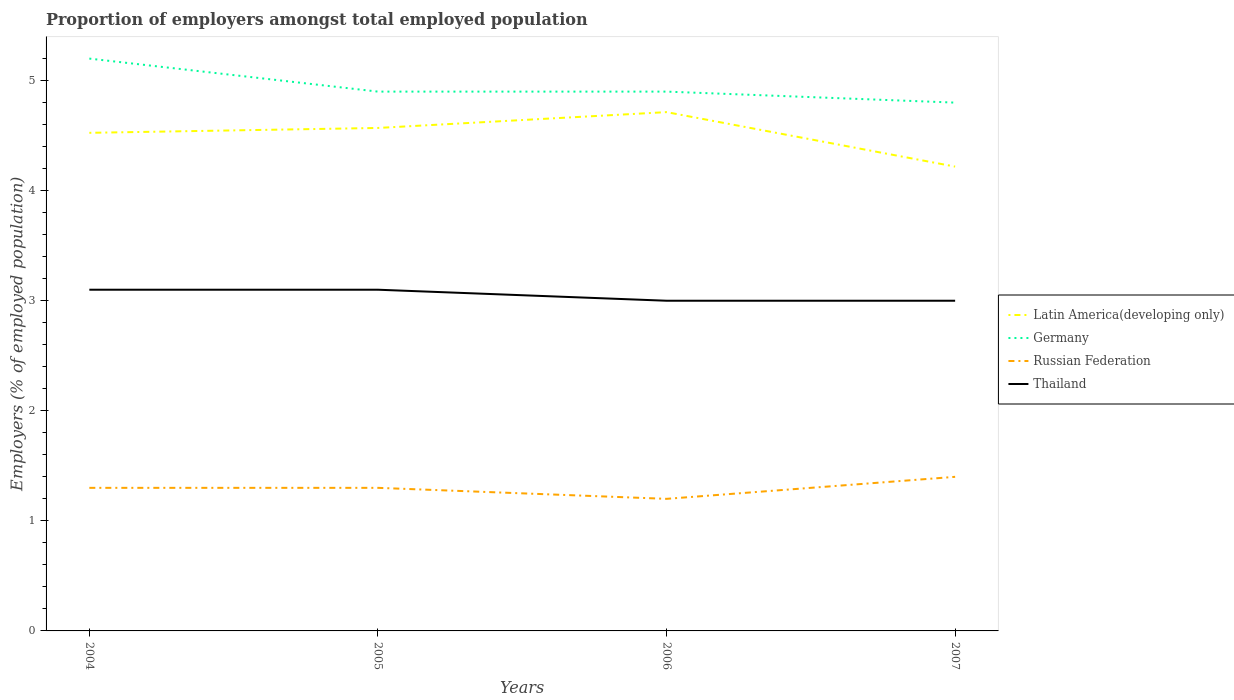Does the line corresponding to Thailand intersect with the line corresponding to Germany?
Your answer should be compact. No. Across all years, what is the maximum proportion of employers in Germany?
Offer a very short reply. 4.8. In which year was the proportion of employers in Thailand maximum?
Give a very brief answer. 2006. What is the total proportion of employers in Russian Federation in the graph?
Give a very brief answer. 0. What is the difference between the highest and the second highest proportion of employers in Germany?
Your answer should be very brief. 0.4. What is the difference between the highest and the lowest proportion of employers in Latin America(developing only)?
Give a very brief answer. 3. How many lines are there?
Make the answer very short. 4. What is the difference between two consecutive major ticks on the Y-axis?
Give a very brief answer. 1. Does the graph contain any zero values?
Give a very brief answer. No. Does the graph contain grids?
Give a very brief answer. No. How many legend labels are there?
Offer a very short reply. 4. What is the title of the graph?
Offer a terse response. Proportion of employers amongst total employed population. What is the label or title of the Y-axis?
Give a very brief answer. Employers (% of employed population). What is the Employers (% of employed population) in Latin America(developing only) in 2004?
Provide a short and direct response. 4.53. What is the Employers (% of employed population) of Germany in 2004?
Provide a succinct answer. 5.2. What is the Employers (% of employed population) of Russian Federation in 2004?
Provide a short and direct response. 1.3. What is the Employers (% of employed population) of Thailand in 2004?
Offer a terse response. 3.1. What is the Employers (% of employed population) in Latin America(developing only) in 2005?
Provide a short and direct response. 4.57. What is the Employers (% of employed population) in Germany in 2005?
Your answer should be compact. 4.9. What is the Employers (% of employed population) in Russian Federation in 2005?
Ensure brevity in your answer.  1.3. What is the Employers (% of employed population) in Thailand in 2005?
Offer a terse response. 3.1. What is the Employers (% of employed population) in Latin America(developing only) in 2006?
Offer a very short reply. 4.71. What is the Employers (% of employed population) of Germany in 2006?
Ensure brevity in your answer.  4.9. What is the Employers (% of employed population) in Russian Federation in 2006?
Make the answer very short. 1.2. What is the Employers (% of employed population) of Latin America(developing only) in 2007?
Your response must be concise. 4.22. What is the Employers (% of employed population) in Germany in 2007?
Provide a succinct answer. 4.8. What is the Employers (% of employed population) of Russian Federation in 2007?
Provide a short and direct response. 1.4. Across all years, what is the maximum Employers (% of employed population) in Latin America(developing only)?
Provide a succinct answer. 4.71. Across all years, what is the maximum Employers (% of employed population) in Germany?
Ensure brevity in your answer.  5.2. Across all years, what is the maximum Employers (% of employed population) in Russian Federation?
Ensure brevity in your answer.  1.4. Across all years, what is the maximum Employers (% of employed population) in Thailand?
Your response must be concise. 3.1. Across all years, what is the minimum Employers (% of employed population) in Latin America(developing only)?
Your response must be concise. 4.22. Across all years, what is the minimum Employers (% of employed population) of Germany?
Your answer should be compact. 4.8. Across all years, what is the minimum Employers (% of employed population) in Russian Federation?
Ensure brevity in your answer.  1.2. What is the total Employers (% of employed population) of Latin America(developing only) in the graph?
Offer a very short reply. 18.03. What is the total Employers (% of employed population) of Germany in the graph?
Your response must be concise. 19.8. What is the difference between the Employers (% of employed population) of Latin America(developing only) in 2004 and that in 2005?
Ensure brevity in your answer.  -0.04. What is the difference between the Employers (% of employed population) of Russian Federation in 2004 and that in 2005?
Provide a short and direct response. 0. What is the difference between the Employers (% of employed population) of Thailand in 2004 and that in 2005?
Your answer should be compact. 0. What is the difference between the Employers (% of employed population) in Latin America(developing only) in 2004 and that in 2006?
Your answer should be compact. -0.19. What is the difference between the Employers (% of employed population) of Latin America(developing only) in 2004 and that in 2007?
Provide a short and direct response. 0.31. What is the difference between the Employers (% of employed population) in Thailand in 2004 and that in 2007?
Your answer should be very brief. 0.1. What is the difference between the Employers (% of employed population) in Latin America(developing only) in 2005 and that in 2006?
Offer a very short reply. -0.14. What is the difference between the Employers (% of employed population) of Germany in 2005 and that in 2006?
Give a very brief answer. 0. What is the difference between the Employers (% of employed population) in Russian Federation in 2005 and that in 2006?
Offer a very short reply. 0.1. What is the difference between the Employers (% of employed population) of Latin America(developing only) in 2005 and that in 2007?
Provide a succinct answer. 0.35. What is the difference between the Employers (% of employed population) in Russian Federation in 2005 and that in 2007?
Your answer should be compact. -0.1. What is the difference between the Employers (% of employed population) in Latin America(developing only) in 2006 and that in 2007?
Keep it short and to the point. 0.49. What is the difference between the Employers (% of employed population) in Russian Federation in 2006 and that in 2007?
Offer a terse response. -0.2. What is the difference between the Employers (% of employed population) in Latin America(developing only) in 2004 and the Employers (% of employed population) in Germany in 2005?
Offer a very short reply. -0.37. What is the difference between the Employers (% of employed population) in Latin America(developing only) in 2004 and the Employers (% of employed population) in Russian Federation in 2005?
Provide a succinct answer. 3.23. What is the difference between the Employers (% of employed population) of Latin America(developing only) in 2004 and the Employers (% of employed population) of Thailand in 2005?
Your answer should be compact. 1.43. What is the difference between the Employers (% of employed population) in Germany in 2004 and the Employers (% of employed population) in Russian Federation in 2005?
Provide a succinct answer. 3.9. What is the difference between the Employers (% of employed population) of Russian Federation in 2004 and the Employers (% of employed population) of Thailand in 2005?
Provide a short and direct response. -1.8. What is the difference between the Employers (% of employed population) of Latin America(developing only) in 2004 and the Employers (% of employed population) of Germany in 2006?
Offer a very short reply. -0.37. What is the difference between the Employers (% of employed population) of Latin America(developing only) in 2004 and the Employers (% of employed population) of Russian Federation in 2006?
Your response must be concise. 3.33. What is the difference between the Employers (% of employed population) of Latin America(developing only) in 2004 and the Employers (% of employed population) of Thailand in 2006?
Provide a short and direct response. 1.53. What is the difference between the Employers (% of employed population) of Latin America(developing only) in 2004 and the Employers (% of employed population) of Germany in 2007?
Ensure brevity in your answer.  -0.27. What is the difference between the Employers (% of employed population) in Latin America(developing only) in 2004 and the Employers (% of employed population) in Russian Federation in 2007?
Offer a very short reply. 3.13. What is the difference between the Employers (% of employed population) in Latin America(developing only) in 2004 and the Employers (% of employed population) in Thailand in 2007?
Make the answer very short. 1.53. What is the difference between the Employers (% of employed population) in Germany in 2004 and the Employers (% of employed population) in Thailand in 2007?
Offer a terse response. 2.2. What is the difference between the Employers (% of employed population) in Latin America(developing only) in 2005 and the Employers (% of employed population) in Germany in 2006?
Your answer should be compact. -0.33. What is the difference between the Employers (% of employed population) in Latin America(developing only) in 2005 and the Employers (% of employed population) in Russian Federation in 2006?
Your response must be concise. 3.37. What is the difference between the Employers (% of employed population) of Latin America(developing only) in 2005 and the Employers (% of employed population) of Thailand in 2006?
Offer a terse response. 1.57. What is the difference between the Employers (% of employed population) in Russian Federation in 2005 and the Employers (% of employed population) in Thailand in 2006?
Offer a terse response. -1.7. What is the difference between the Employers (% of employed population) in Latin America(developing only) in 2005 and the Employers (% of employed population) in Germany in 2007?
Your answer should be very brief. -0.23. What is the difference between the Employers (% of employed population) in Latin America(developing only) in 2005 and the Employers (% of employed population) in Russian Federation in 2007?
Your answer should be compact. 3.17. What is the difference between the Employers (% of employed population) of Latin America(developing only) in 2005 and the Employers (% of employed population) of Thailand in 2007?
Offer a terse response. 1.57. What is the difference between the Employers (% of employed population) in Latin America(developing only) in 2006 and the Employers (% of employed population) in Germany in 2007?
Make the answer very short. -0.09. What is the difference between the Employers (% of employed population) in Latin America(developing only) in 2006 and the Employers (% of employed population) in Russian Federation in 2007?
Ensure brevity in your answer.  3.31. What is the difference between the Employers (% of employed population) in Latin America(developing only) in 2006 and the Employers (% of employed population) in Thailand in 2007?
Keep it short and to the point. 1.71. What is the difference between the Employers (% of employed population) in Russian Federation in 2006 and the Employers (% of employed population) in Thailand in 2007?
Offer a very short reply. -1.8. What is the average Employers (% of employed population) of Latin America(developing only) per year?
Give a very brief answer. 4.51. What is the average Employers (% of employed population) of Germany per year?
Offer a very short reply. 4.95. What is the average Employers (% of employed population) of Russian Federation per year?
Your answer should be very brief. 1.3. What is the average Employers (% of employed population) in Thailand per year?
Offer a terse response. 3.05. In the year 2004, what is the difference between the Employers (% of employed population) in Latin America(developing only) and Employers (% of employed population) in Germany?
Ensure brevity in your answer.  -0.67. In the year 2004, what is the difference between the Employers (% of employed population) of Latin America(developing only) and Employers (% of employed population) of Russian Federation?
Provide a short and direct response. 3.23. In the year 2004, what is the difference between the Employers (% of employed population) of Latin America(developing only) and Employers (% of employed population) of Thailand?
Offer a terse response. 1.43. In the year 2004, what is the difference between the Employers (% of employed population) of Germany and Employers (% of employed population) of Thailand?
Provide a short and direct response. 2.1. In the year 2004, what is the difference between the Employers (% of employed population) in Russian Federation and Employers (% of employed population) in Thailand?
Your answer should be compact. -1.8. In the year 2005, what is the difference between the Employers (% of employed population) of Latin America(developing only) and Employers (% of employed population) of Germany?
Give a very brief answer. -0.33. In the year 2005, what is the difference between the Employers (% of employed population) in Latin America(developing only) and Employers (% of employed population) in Russian Federation?
Offer a very short reply. 3.27. In the year 2005, what is the difference between the Employers (% of employed population) of Latin America(developing only) and Employers (% of employed population) of Thailand?
Offer a terse response. 1.47. In the year 2005, what is the difference between the Employers (% of employed population) in Germany and Employers (% of employed population) in Russian Federation?
Provide a short and direct response. 3.6. In the year 2005, what is the difference between the Employers (% of employed population) of Russian Federation and Employers (% of employed population) of Thailand?
Provide a short and direct response. -1.8. In the year 2006, what is the difference between the Employers (% of employed population) in Latin America(developing only) and Employers (% of employed population) in Germany?
Your answer should be very brief. -0.19. In the year 2006, what is the difference between the Employers (% of employed population) in Latin America(developing only) and Employers (% of employed population) in Russian Federation?
Ensure brevity in your answer.  3.51. In the year 2006, what is the difference between the Employers (% of employed population) of Latin America(developing only) and Employers (% of employed population) of Thailand?
Your answer should be compact. 1.71. In the year 2006, what is the difference between the Employers (% of employed population) of Germany and Employers (% of employed population) of Russian Federation?
Make the answer very short. 3.7. In the year 2007, what is the difference between the Employers (% of employed population) of Latin America(developing only) and Employers (% of employed population) of Germany?
Keep it short and to the point. -0.58. In the year 2007, what is the difference between the Employers (% of employed population) of Latin America(developing only) and Employers (% of employed population) of Russian Federation?
Offer a terse response. 2.82. In the year 2007, what is the difference between the Employers (% of employed population) in Latin America(developing only) and Employers (% of employed population) in Thailand?
Your answer should be very brief. 1.22. What is the ratio of the Employers (% of employed population) in Latin America(developing only) in 2004 to that in 2005?
Your answer should be very brief. 0.99. What is the ratio of the Employers (% of employed population) of Germany in 2004 to that in 2005?
Provide a succinct answer. 1.06. What is the ratio of the Employers (% of employed population) of Russian Federation in 2004 to that in 2005?
Keep it short and to the point. 1. What is the ratio of the Employers (% of employed population) of Latin America(developing only) in 2004 to that in 2006?
Ensure brevity in your answer.  0.96. What is the ratio of the Employers (% of employed population) in Germany in 2004 to that in 2006?
Offer a very short reply. 1.06. What is the ratio of the Employers (% of employed population) in Russian Federation in 2004 to that in 2006?
Provide a short and direct response. 1.08. What is the ratio of the Employers (% of employed population) of Latin America(developing only) in 2004 to that in 2007?
Offer a very short reply. 1.07. What is the ratio of the Employers (% of employed population) of Germany in 2004 to that in 2007?
Offer a very short reply. 1.08. What is the ratio of the Employers (% of employed population) of Latin America(developing only) in 2005 to that in 2006?
Offer a very short reply. 0.97. What is the ratio of the Employers (% of employed population) of Russian Federation in 2005 to that in 2006?
Provide a short and direct response. 1.08. What is the ratio of the Employers (% of employed population) of Thailand in 2005 to that in 2006?
Provide a succinct answer. 1.03. What is the ratio of the Employers (% of employed population) of Latin America(developing only) in 2005 to that in 2007?
Provide a short and direct response. 1.08. What is the ratio of the Employers (% of employed population) of Germany in 2005 to that in 2007?
Ensure brevity in your answer.  1.02. What is the ratio of the Employers (% of employed population) of Russian Federation in 2005 to that in 2007?
Give a very brief answer. 0.93. What is the ratio of the Employers (% of employed population) of Latin America(developing only) in 2006 to that in 2007?
Make the answer very short. 1.12. What is the ratio of the Employers (% of employed population) of Germany in 2006 to that in 2007?
Your answer should be compact. 1.02. What is the ratio of the Employers (% of employed population) of Thailand in 2006 to that in 2007?
Your response must be concise. 1. What is the difference between the highest and the second highest Employers (% of employed population) in Latin America(developing only)?
Keep it short and to the point. 0.14. What is the difference between the highest and the lowest Employers (% of employed population) in Latin America(developing only)?
Give a very brief answer. 0.49. What is the difference between the highest and the lowest Employers (% of employed population) of Russian Federation?
Make the answer very short. 0.2. What is the difference between the highest and the lowest Employers (% of employed population) of Thailand?
Your answer should be compact. 0.1. 